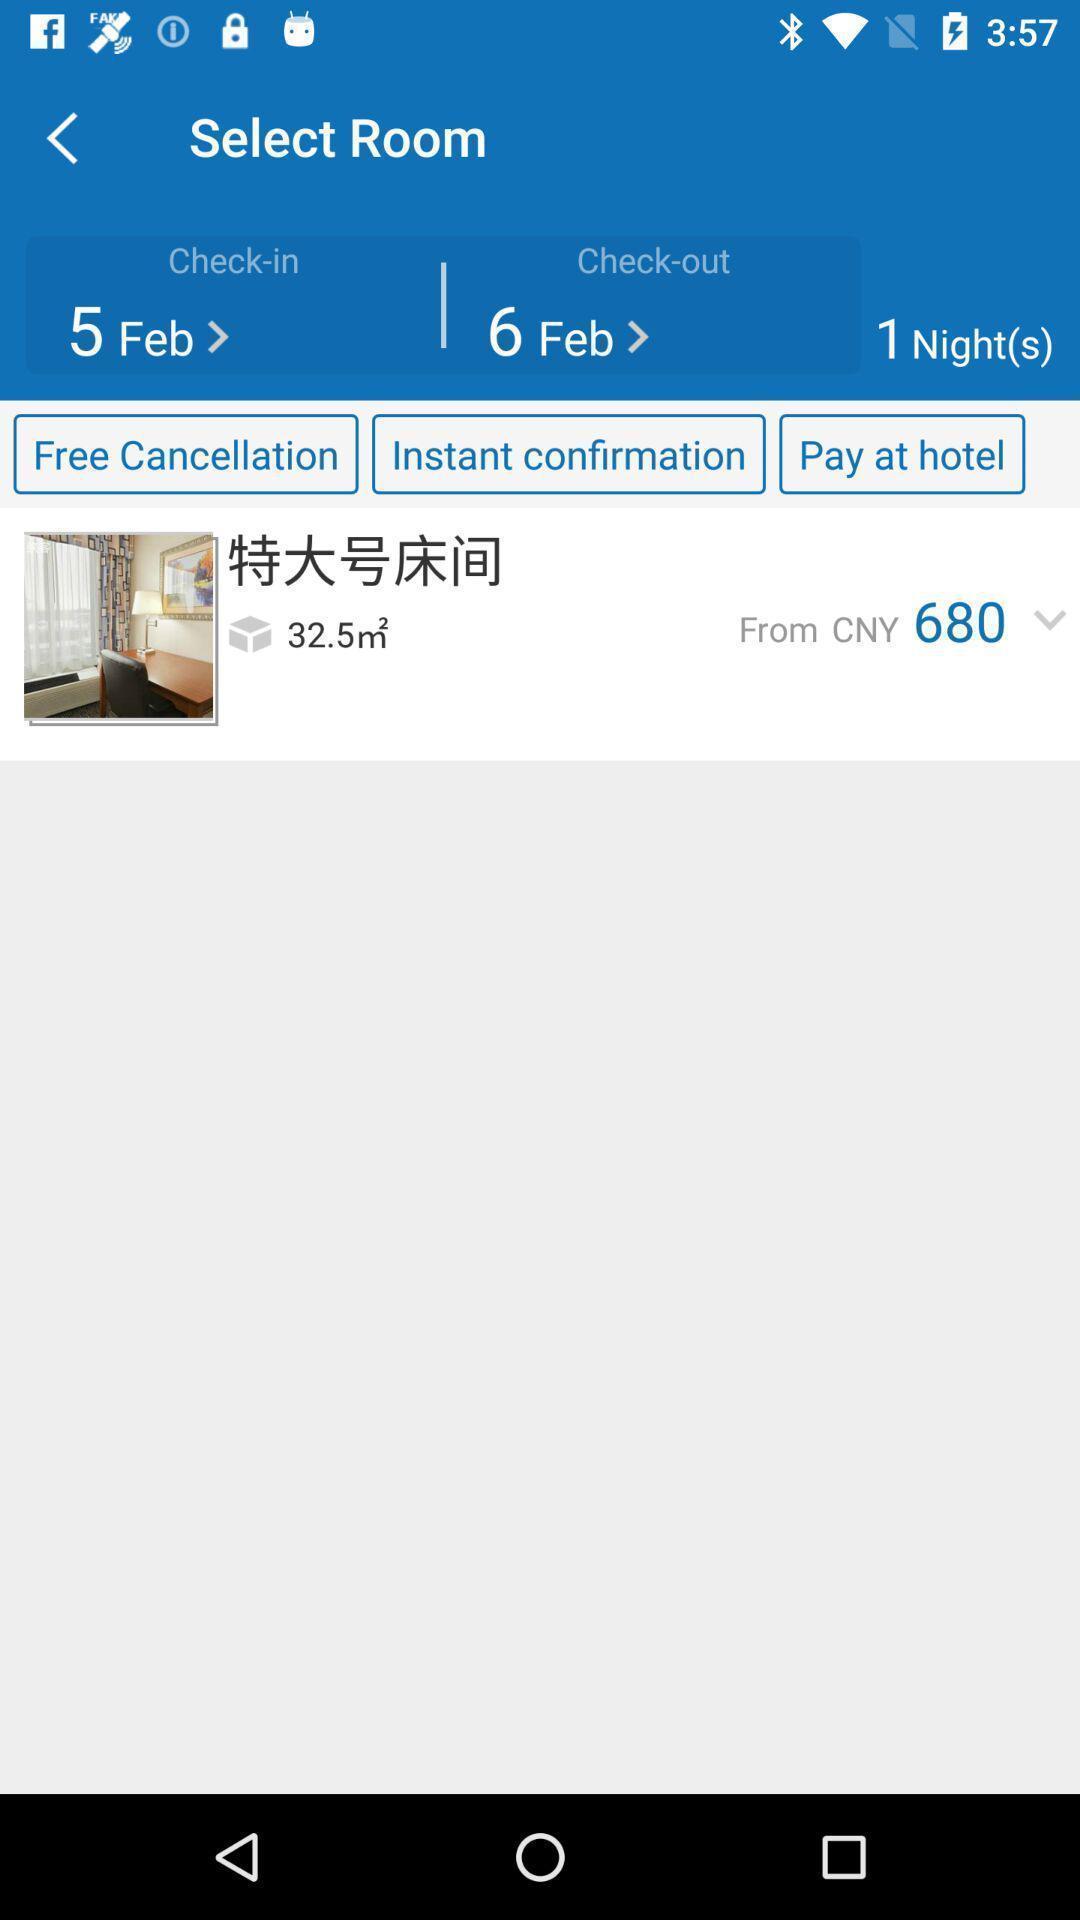Please provide a description for this image. Page showing the rooms available. 